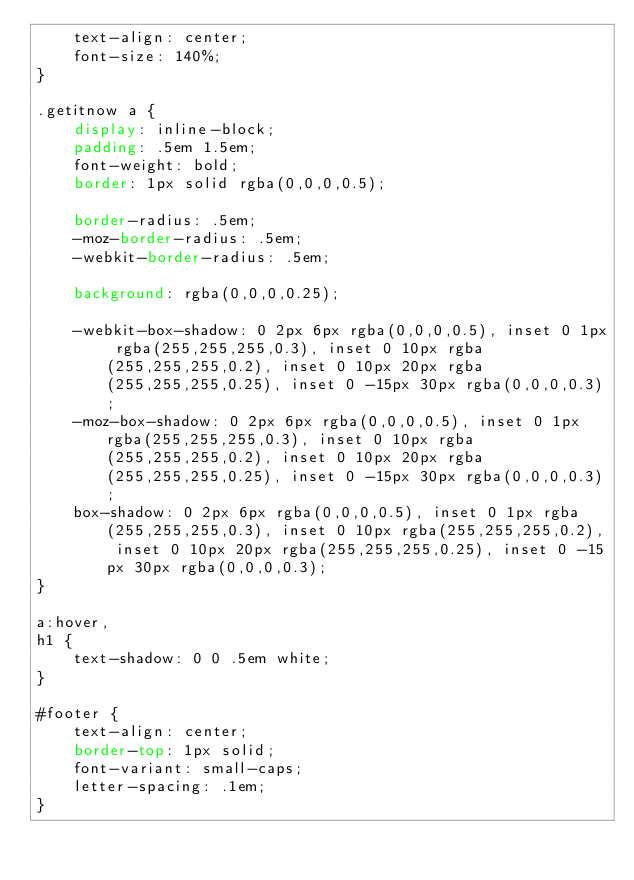<code> <loc_0><loc_0><loc_500><loc_500><_CSS_>	text-align: center;
	font-size: 140%;
}

.getitnow a {
	display: inline-block;
	padding: .5em 1.5em;
	font-weight: bold;
	border: 1px solid rgba(0,0,0,0.5);
	
	border-radius: .5em;
	-moz-border-radius: .5em;
	-webkit-border-radius: .5em;
	
	background: rgba(0,0,0,0.25);
	
	-webkit-box-shadow: 0 2px 6px rgba(0,0,0,0.5), inset 0 1px rgba(255,255,255,0.3), inset 0 10px rgba(255,255,255,0.2), inset 0 10px 20px rgba(255,255,255,0.25), inset 0 -15px 30px rgba(0,0,0,0.3);
	-moz-box-shadow: 0 2px 6px rgba(0,0,0,0.5), inset 0 1px rgba(255,255,255,0.3), inset 0 10px rgba(255,255,255,0.2), inset 0 10px 20px rgba(255,255,255,0.25), inset 0 -15px 30px rgba(0,0,0,0.3);
	box-shadow: 0 2px 6px rgba(0,0,0,0.5), inset 0 1px rgba(255,255,255,0.3), inset 0 10px rgba(255,255,255,0.2), inset 0 10px 20px rgba(255,255,255,0.25), inset 0 -15px 30px rgba(0,0,0,0.3);
}

a:hover,
h1 {
	text-shadow: 0 0 .5em white;
}

#footer {
	text-align: center;
	border-top: 1px solid;
	font-variant: small-caps;
	letter-spacing: .1em;
}
</code> 